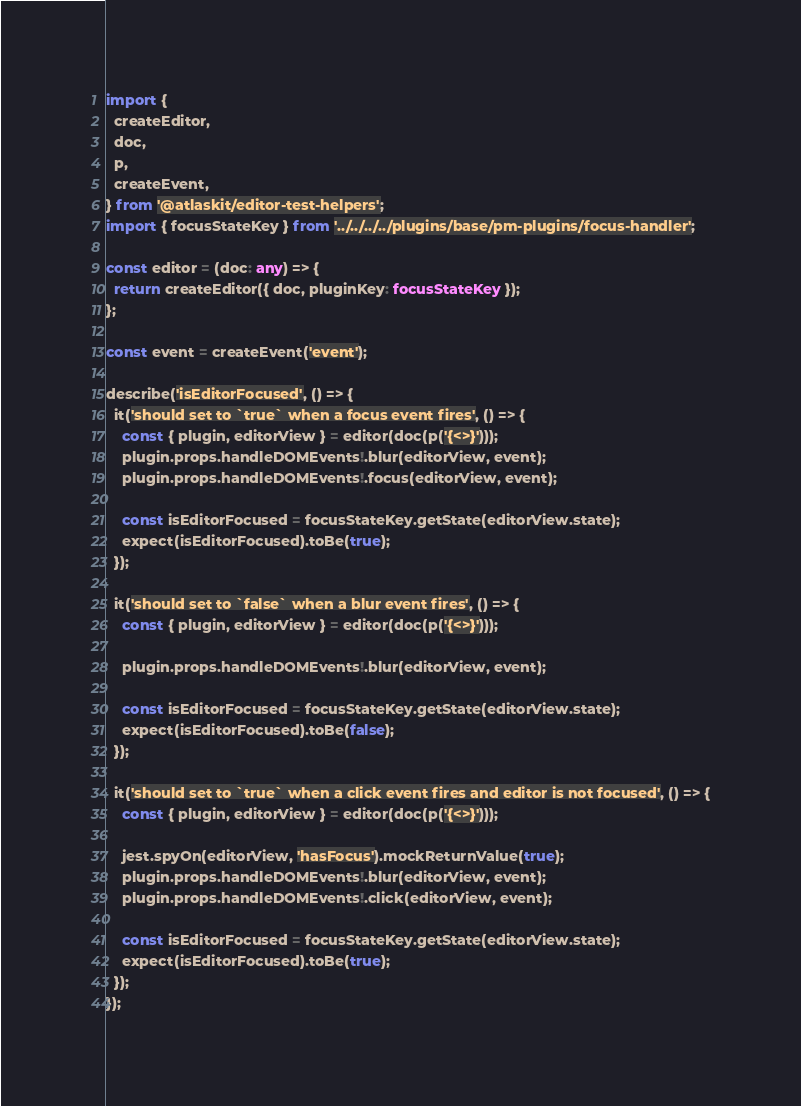Convert code to text. <code><loc_0><loc_0><loc_500><loc_500><_TypeScript_>import {
  createEditor,
  doc,
  p,
  createEvent,
} from '@atlaskit/editor-test-helpers';
import { focusStateKey } from '../../../../plugins/base/pm-plugins/focus-handler';

const editor = (doc: any) => {
  return createEditor({ doc, pluginKey: focusStateKey });
};

const event = createEvent('event');

describe('isEditorFocused', () => {
  it('should set to `true` when a focus event fires', () => {
    const { plugin, editorView } = editor(doc(p('{<>}')));
    plugin.props.handleDOMEvents!.blur(editorView, event);
    plugin.props.handleDOMEvents!.focus(editorView, event);

    const isEditorFocused = focusStateKey.getState(editorView.state);
    expect(isEditorFocused).toBe(true);
  });

  it('should set to `false` when a blur event fires', () => {
    const { plugin, editorView } = editor(doc(p('{<>}')));

    plugin.props.handleDOMEvents!.blur(editorView, event);

    const isEditorFocused = focusStateKey.getState(editorView.state);
    expect(isEditorFocused).toBe(false);
  });

  it('should set to `true` when a click event fires and editor is not focused', () => {
    const { plugin, editorView } = editor(doc(p('{<>}')));

    jest.spyOn(editorView, 'hasFocus').mockReturnValue(true);
    plugin.props.handleDOMEvents!.blur(editorView, event);
    plugin.props.handleDOMEvents!.click(editorView, event);

    const isEditorFocused = focusStateKey.getState(editorView.state);
    expect(isEditorFocused).toBe(true);
  });
});
</code> 